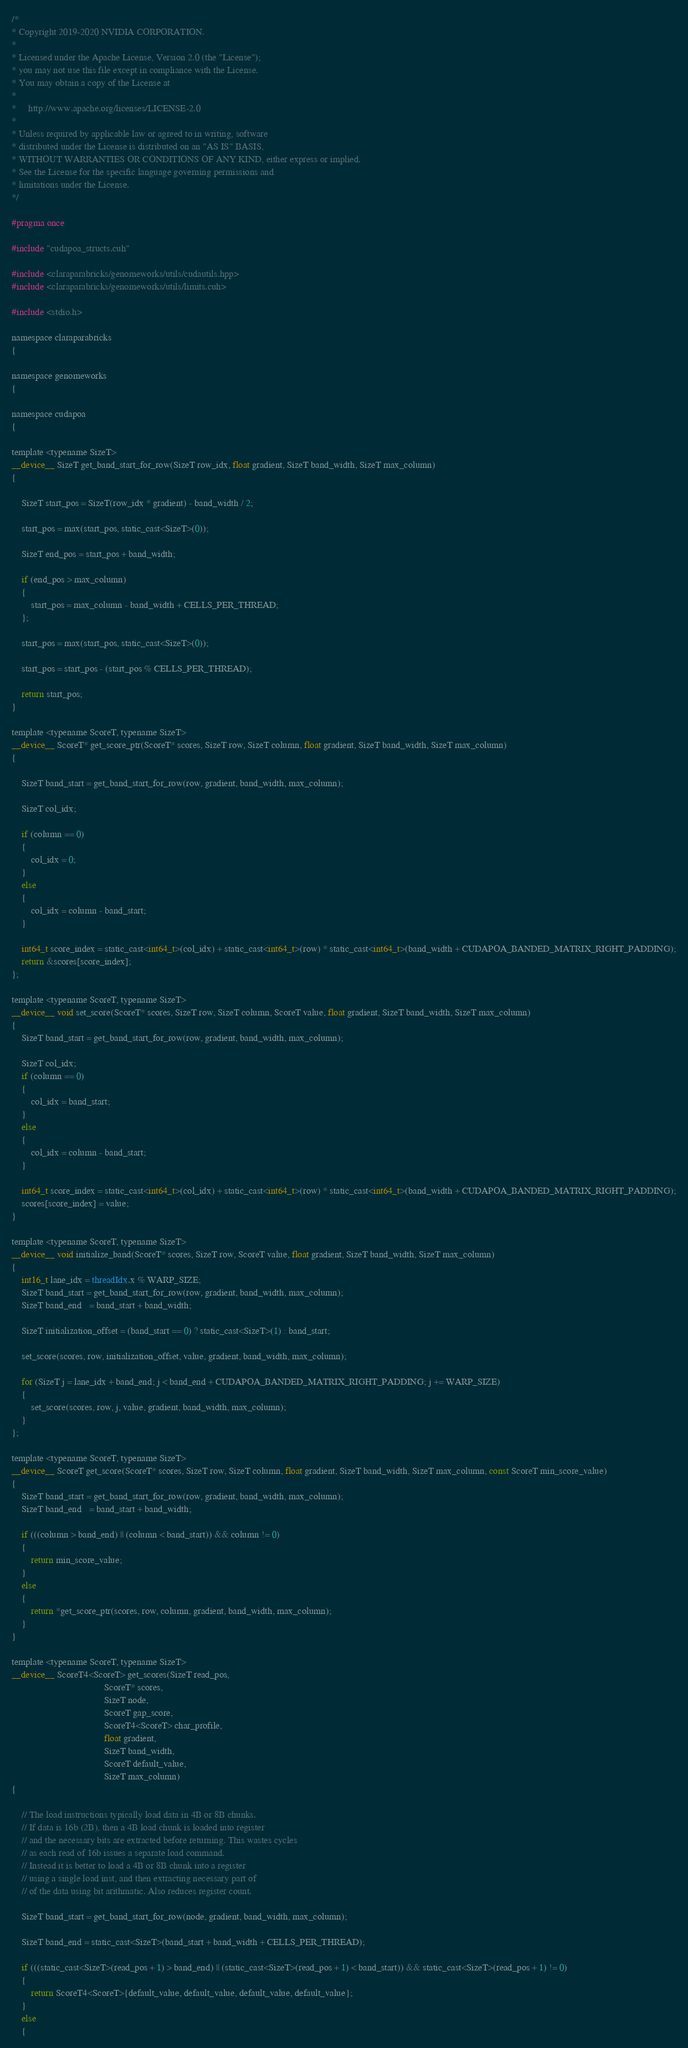<code> <loc_0><loc_0><loc_500><loc_500><_Cuda_>/*
* Copyright 2019-2020 NVIDIA CORPORATION.
*
* Licensed under the Apache License, Version 2.0 (the "License");
* you may not use this file except in compliance with the License.
* You may obtain a copy of the License at
*
*     http://www.apache.org/licenses/LICENSE-2.0
*
* Unless required by applicable law or agreed to in writing, software
* distributed under the License is distributed on an "AS IS" BASIS,
* WITHOUT WARRANTIES OR CONDITIONS OF ANY KIND, either express or implied.
* See the License for the specific language governing permissions and
* limitations under the License.
*/

#pragma once

#include "cudapoa_structs.cuh"

#include <claraparabricks/genomeworks/utils/cudautils.hpp>
#include <claraparabricks/genomeworks/utils/limits.cuh>

#include <stdio.h>

namespace claraparabricks
{

namespace genomeworks
{

namespace cudapoa
{

template <typename SizeT>
__device__ SizeT get_band_start_for_row(SizeT row_idx, float gradient, SizeT band_width, SizeT max_column)
{

    SizeT start_pos = SizeT(row_idx * gradient) - band_width / 2;

    start_pos = max(start_pos, static_cast<SizeT>(0));

    SizeT end_pos = start_pos + band_width;

    if (end_pos > max_column)
    {
        start_pos = max_column - band_width + CELLS_PER_THREAD;
    };

    start_pos = max(start_pos, static_cast<SizeT>(0));

    start_pos = start_pos - (start_pos % CELLS_PER_THREAD);

    return start_pos;
}

template <typename ScoreT, typename SizeT>
__device__ ScoreT* get_score_ptr(ScoreT* scores, SizeT row, SizeT column, float gradient, SizeT band_width, SizeT max_column)
{

    SizeT band_start = get_band_start_for_row(row, gradient, band_width, max_column);

    SizeT col_idx;

    if (column == 0)
    {
        col_idx = 0;
    }
    else
    {
        col_idx = column - band_start;
    }

    int64_t score_index = static_cast<int64_t>(col_idx) + static_cast<int64_t>(row) * static_cast<int64_t>(band_width + CUDAPOA_BANDED_MATRIX_RIGHT_PADDING);
    return &scores[score_index];
};

template <typename ScoreT, typename SizeT>
__device__ void set_score(ScoreT* scores, SizeT row, SizeT column, ScoreT value, float gradient, SizeT band_width, SizeT max_column)
{
    SizeT band_start = get_band_start_for_row(row, gradient, band_width, max_column);

    SizeT col_idx;
    if (column == 0)
    {
        col_idx = band_start;
    }
    else
    {
        col_idx = column - band_start;
    }

    int64_t score_index = static_cast<int64_t>(col_idx) + static_cast<int64_t>(row) * static_cast<int64_t>(band_width + CUDAPOA_BANDED_MATRIX_RIGHT_PADDING);
    scores[score_index] = value;
}

template <typename ScoreT, typename SizeT>
__device__ void initialize_band(ScoreT* scores, SizeT row, ScoreT value, float gradient, SizeT band_width, SizeT max_column)
{
    int16_t lane_idx = threadIdx.x % WARP_SIZE;
    SizeT band_start = get_band_start_for_row(row, gradient, band_width, max_column);
    SizeT band_end   = band_start + band_width;

    SizeT initialization_offset = (band_start == 0) ? static_cast<SizeT>(1) : band_start;

    set_score(scores, row, initialization_offset, value, gradient, band_width, max_column);

    for (SizeT j = lane_idx + band_end; j < band_end + CUDAPOA_BANDED_MATRIX_RIGHT_PADDING; j += WARP_SIZE)
    {
        set_score(scores, row, j, value, gradient, band_width, max_column);
    }
};

template <typename ScoreT, typename SizeT>
__device__ ScoreT get_score(ScoreT* scores, SizeT row, SizeT column, float gradient, SizeT band_width, SizeT max_column, const ScoreT min_score_value)
{
    SizeT band_start = get_band_start_for_row(row, gradient, band_width, max_column);
    SizeT band_end   = band_start + band_width;

    if (((column > band_end) || (column < band_start)) && column != 0)
    {
        return min_score_value;
    }
    else
    {
        return *get_score_ptr(scores, row, column, gradient, band_width, max_column);
    }
}

template <typename ScoreT, typename SizeT>
__device__ ScoreT4<ScoreT> get_scores(SizeT read_pos,
                                      ScoreT* scores,
                                      SizeT node,
                                      ScoreT gap_score,
                                      ScoreT4<ScoreT> char_profile,
                                      float gradient,
                                      SizeT band_width,
                                      ScoreT default_value,
                                      SizeT max_column)
{

    // The load instructions typically load data in 4B or 8B chunks.
    // If data is 16b (2B), then a 4B load chunk is loaded into register
    // and the necessary bits are extracted before returning. This wastes cycles
    // as each read of 16b issues a separate load command.
    // Instead it is better to load a 4B or 8B chunk into a register
    // using a single load inst, and then extracting necessary part of
    // of the data using bit arithmatic. Also reduces register count.

    SizeT band_start = get_band_start_for_row(node, gradient, band_width, max_column);

    SizeT band_end = static_cast<SizeT>(band_start + band_width + CELLS_PER_THREAD);

    if (((static_cast<SizeT>(read_pos + 1) > band_end) || (static_cast<SizeT>(read_pos + 1) < band_start)) && static_cast<SizeT>(read_pos + 1) != 0)
    {
        return ScoreT4<ScoreT>{default_value, default_value, default_value, default_value};
    }
    else
    {</code> 